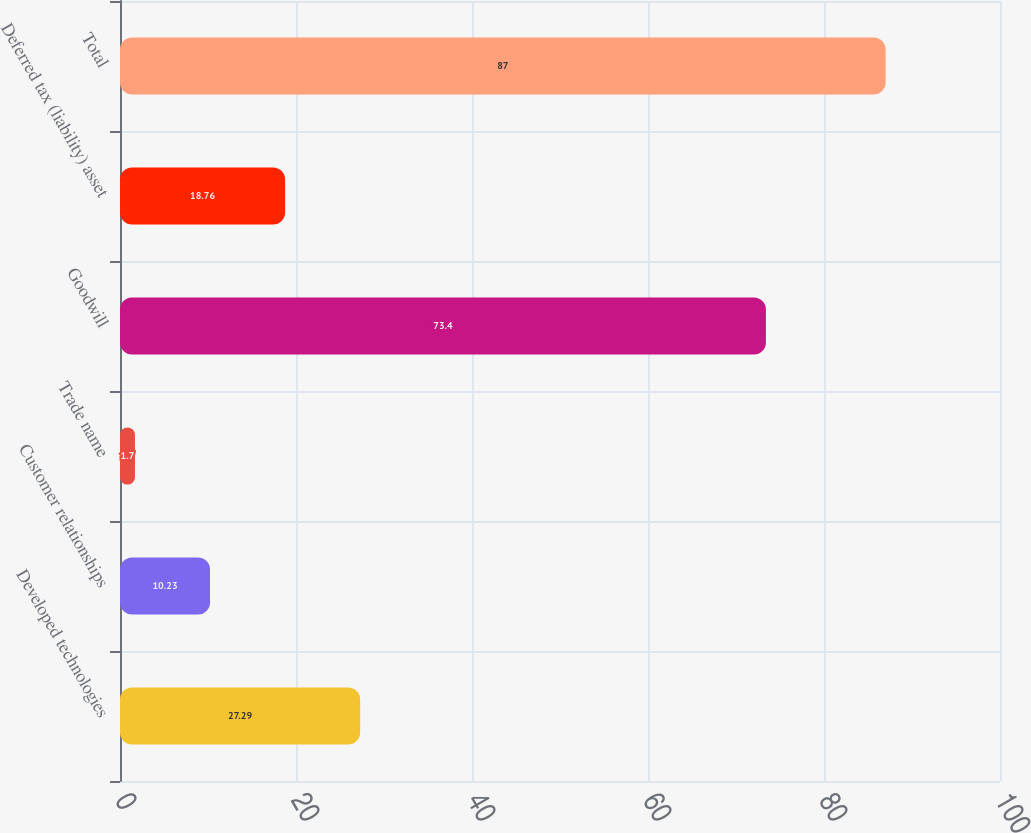Convert chart to OTSL. <chart><loc_0><loc_0><loc_500><loc_500><bar_chart><fcel>Developed technologies<fcel>Customer relationships<fcel>Trade name<fcel>Goodwill<fcel>Deferred tax (liability) asset<fcel>Total<nl><fcel>27.29<fcel>10.23<fcel>1.7<fcel>73.4<fcel>18.76<fcel>87<nl></chart> 